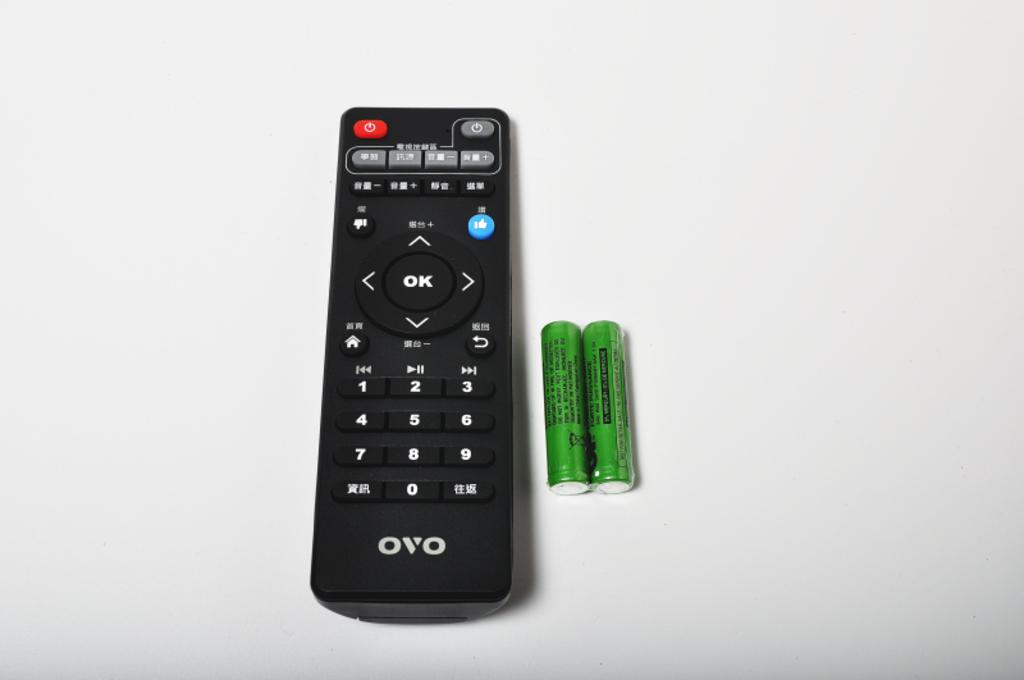What type of remote is visible in the image? There is a black remote in the image. What color are the remote cells in the image? The remote cells are green in color. How many green color remote cells are present in the image? There are two green color remote cells in the image. Where are the green color remote cells located in relation to the black remote? The green color remote cells are beside the black remote. What type of wool is being used to comfort the baby in the image? There is no baby or wool present in the image; it only features a black remote and two green color remote cells. 